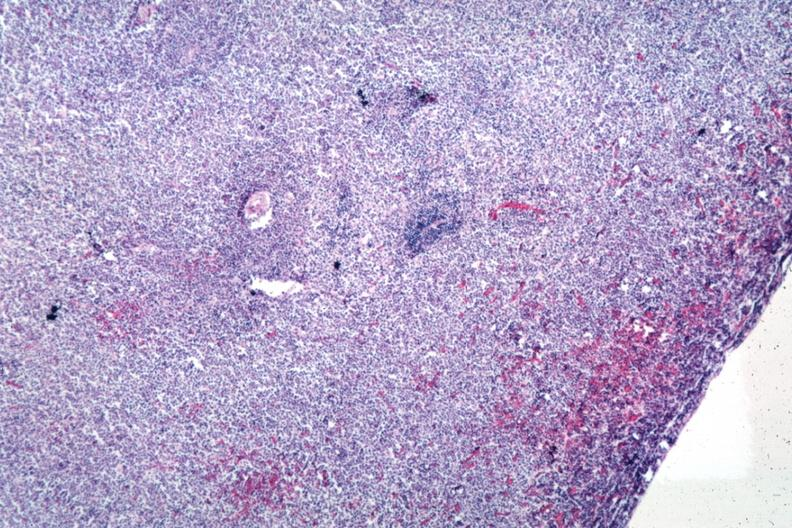what does this image show?
Answer the question using a single word or phrase. Sheets of lymphoma cells 